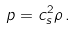<formula> <loc_0><loc_0><loc_500><loc_500>p = c _ { s } ^ { 2 } \rho \, .</formula> 